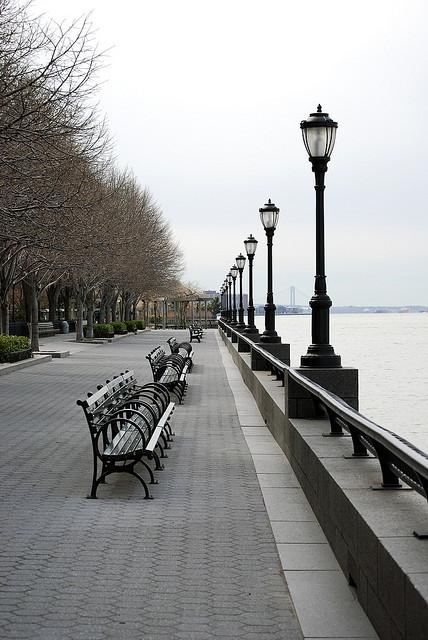How many benches are occupied?
Keep it brief. 0. What powers the lamps?
Be succinct. Electricity. If people were sitting down, what is the view?
Quick response, please. Water. 